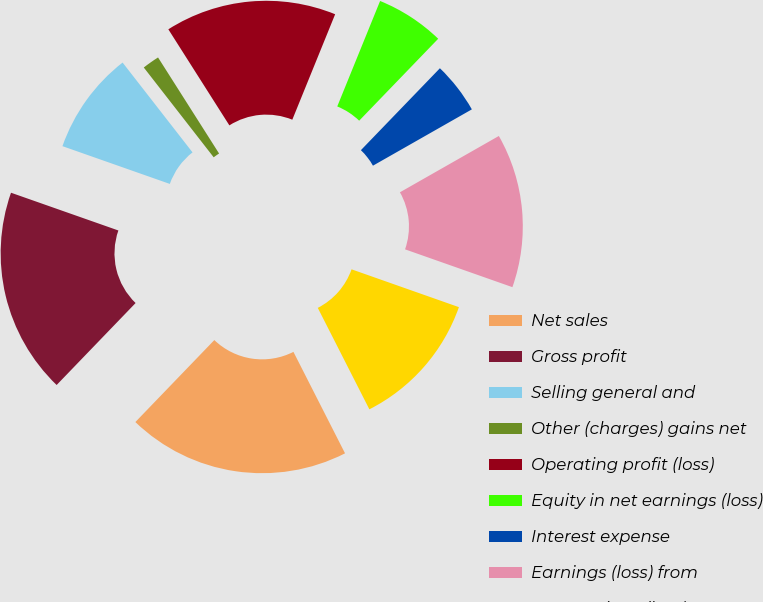Convert chart to OTSL. <chart><loc_0><loc_0><loc_500><loc_500><pie_chart><fcel>Net sales<fcel>Gross profit<fcel>Selling general and<fcel>Other (charges) gains net<fcel>Operating profit (loss)<fcel>Equity in net earnings (loss)<fcel>Interest expense<fcel>Earnings (loss) from<fcel>Net earnings (loss)<nl><fcel>19.69%<fcel>18.18%<fcel>9.09%<fcel>1.52%<fcel>15.15%<fcel>6.07%<fcel>4.55%<fcel>13.63%<fcel>12.12%<nl></chart> 